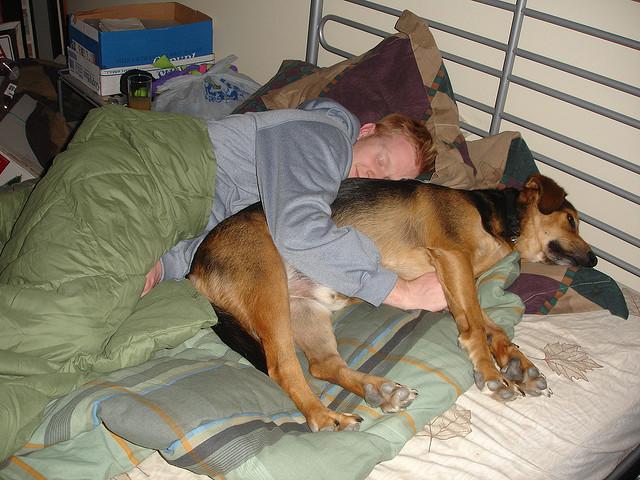What is one thing on the bedside table?
Give a very brief answer. Box. What kind of dog?
Short answer required. Mutt. What color is the blanket the man is under?
Give a very brief answer. Green. 